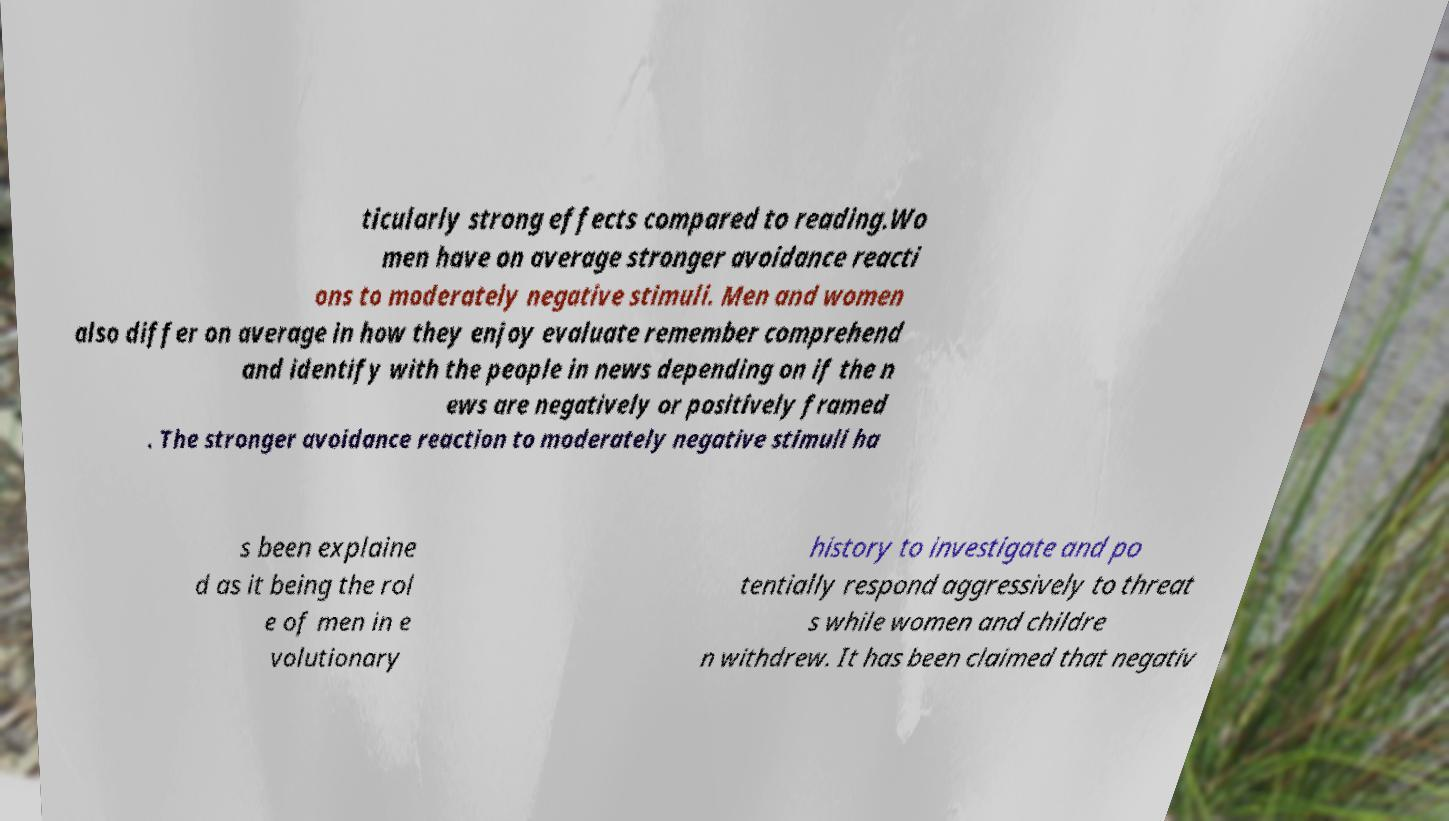Can you accurately transcribe the text from the provided image for me? ticularly strong effects compared to reading.Wo men have on average stronger avoidance reacti ons to moderately negative stimuli. Men and women also differ on average in how they enjoy evaluate remember comprehend and identify with the people in news depending on if the n ews are negatively or positively framed . The stronger avoidance reaction to moderately negative stimuli ha s been explaine d as it being the rol e of men in e volutionary history to investigate and po tentially respond aggressively to threat s while women and childre n withdrew. It has been claimed that negativ 